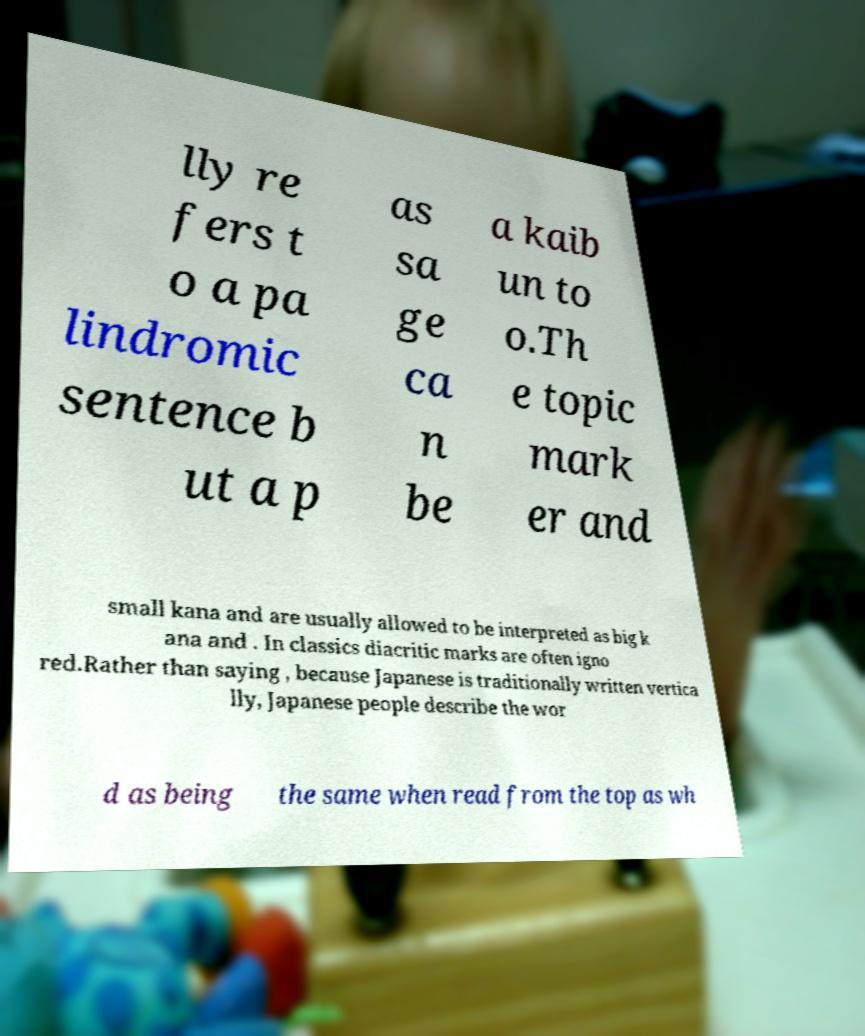Could you extract and type out the text from this image? lly re fers t o a pa lindromic sentence b ut a p as sa ge ca n be a kaib un to o.Th e topic mark er and small kana and are usually allowed to be interpreted as big k ana and . In classics diacritic marks are often igno red.Rather than saying , because Japanese is traditionally written vertica lly, Japanese people describe the wor d as being the same when read from the top as wh 